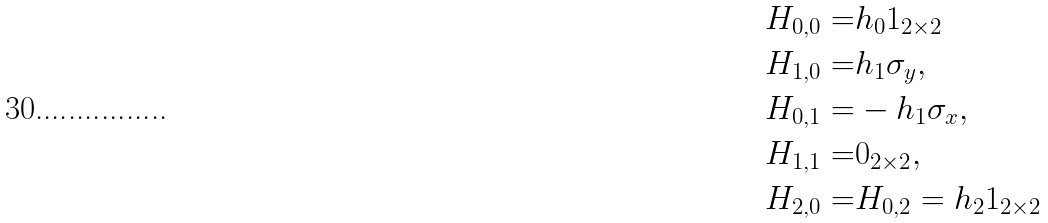<formula> <loc_0><loc_0><loc_500><loc_500>H _ { 0 , 0 } = & h _ { 0 } 1 _ { 2 \times 2 } \\ H _ { 1 , 0 } = & h _ { 1 } \sigma _ { y } , \\ H _ { 0 , 1 } = & - h _ { 1 } \sigma _ { x } , \\ H _ { 1 , 1 } = & 0 _ { 2 \times 2 } , \\ H _ { 2 , 0 } = & H _ { 0 , 2 } = h _ { 2 } 1 _ { 2 \times 2 }</formula> 